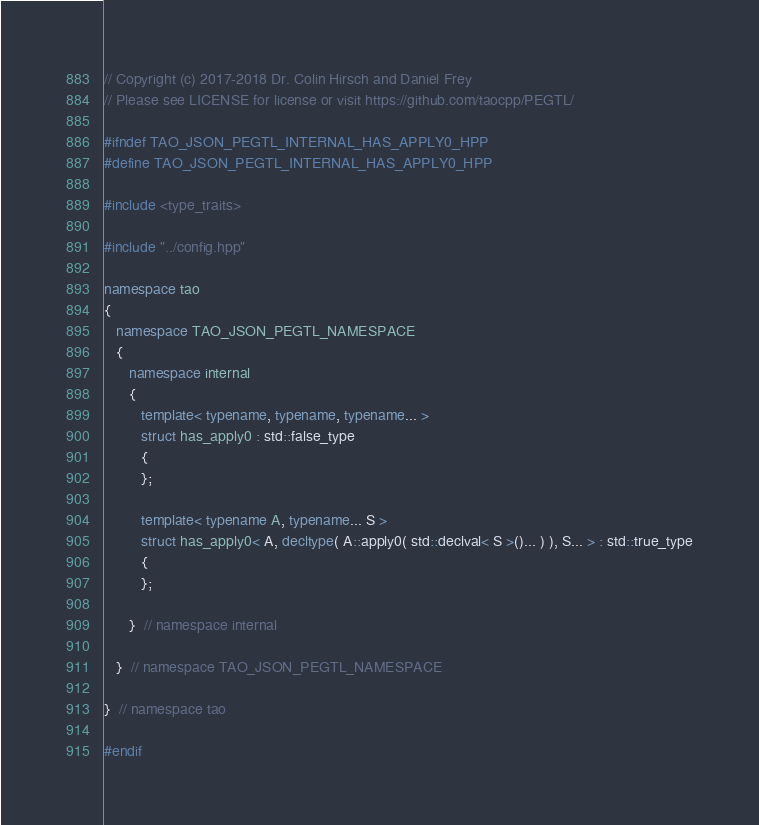Convert code to text. <code><loc_0><loc_0><loc_500><loc_500><_C++_>// Copyright (c) 2017-2018 Dr. Colin Hirsch and Daniel Frey
// Please see LICENSE for license or visit https://github.com/taocpp/PEGTL/

#ifndef TAO_JSON_PEGTL_INTERNAL_HAS_APPLY0_HPP
#define TAO_JSON_PEGTL_INTERNAL_HAS_APPLY0_HPP

#include <type_traits>

#include "../config.hpp"

namespace tao
{
   namespace TAO_JSON_PEGTL_NAMESPACE
   {
      namespace internal
      {
         template< typename, typename, typename... >
         struct has_apply0 : std::false_type
         {
         };

         template< typename A, typename... S >
         struct has_apply0< A, decltype( A::apply0( std::declval< S >()... ) ), S... > : std::true_type
         {
         };

      }  // namespace internal

   }  // namespace TAO_JSON_PEGTL_NAMESPACE

}  // namespace tao

#endif
</code> 